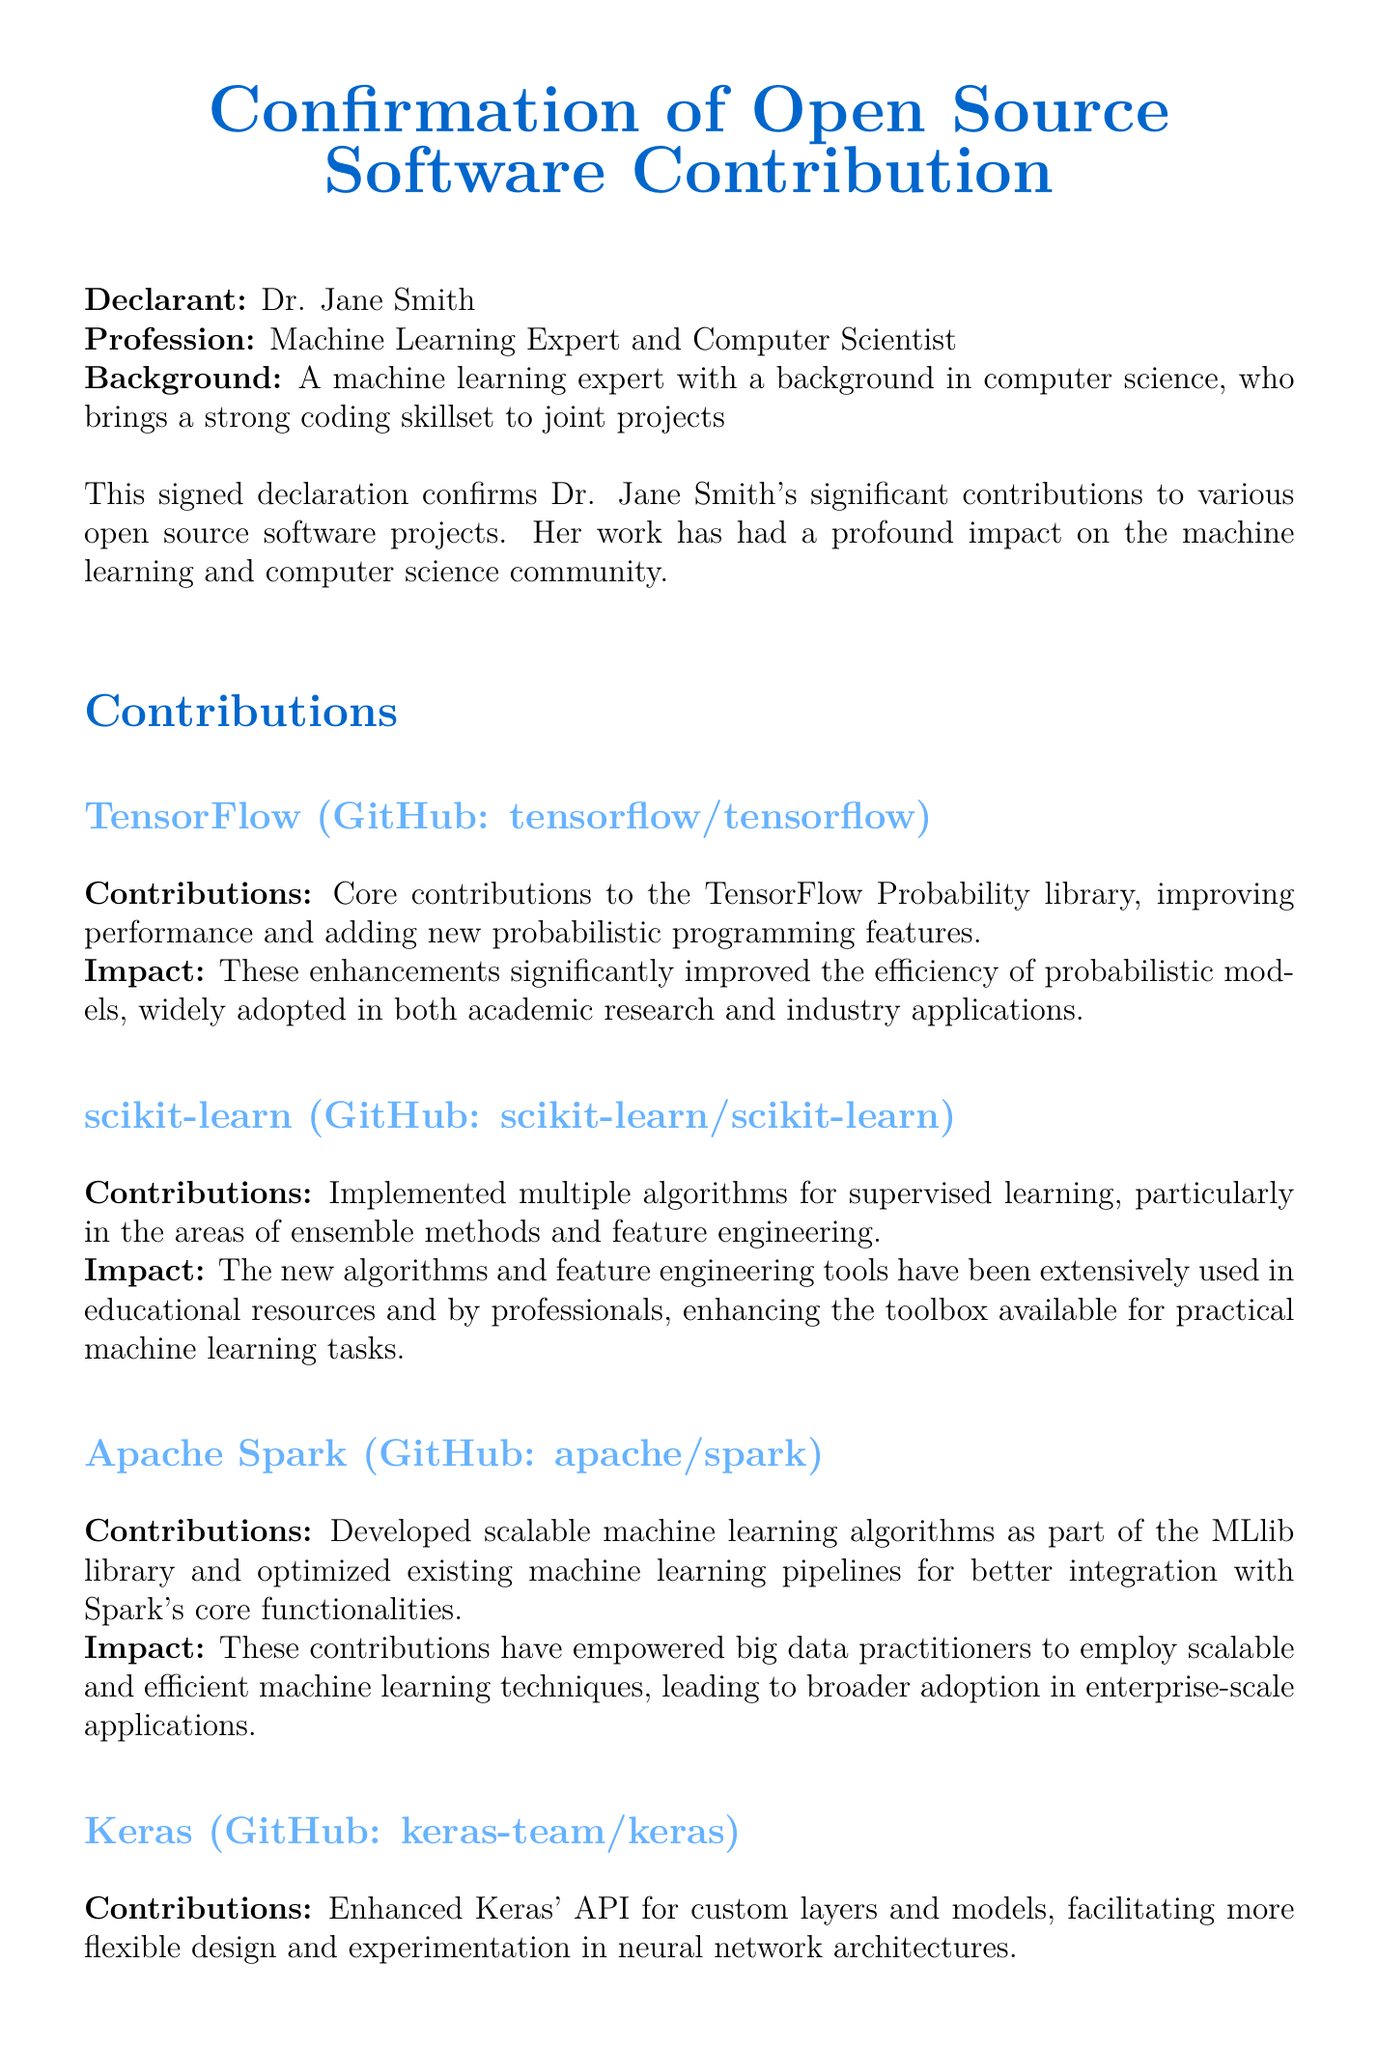What is the name of the declarant? The name of the declarant is stated at the beginning of the document.
Answer: Dr. Jane Smith What is Dr. Jane Smith's profession? The document specifically mentions the profession of the declarant.
Answer: Machine Learning Expert and Computer Scientist Which library did Dr. Jane Smith contribute to regarding probabilistic programming? The document lists the specific contributions to different libraries, including TensorFlow Probability.
Answer: TensorFlow Probability What major feature did Dr. Jane Smith enhance in Keras? The contributions section describes the specific enhancements made in Keras.
Answer: API for custom layers and models How many open source projects are mentioned in the document? By counting the listed contributions, we can determine how many projects are referenced.
Answer: Four What impact did the contributions to scikit-learn have? The document states the impact of the contributions regarding their usage by professionals and educational resources.
Answer: Enhancing the toolbox available for practical machine learning tasks Which GitHub repository is associated with Apache Spark? The document provides the GitHub reference associated with Dr. Jane Smith's contributions.
Answer: apache/spark What specific area of machine learning did Dr. Jane Smith focus on for MLlib? This can be determined from the description of contributions made in the section related to Apache Spark.
Answer: Scalable machine learning algorithms 